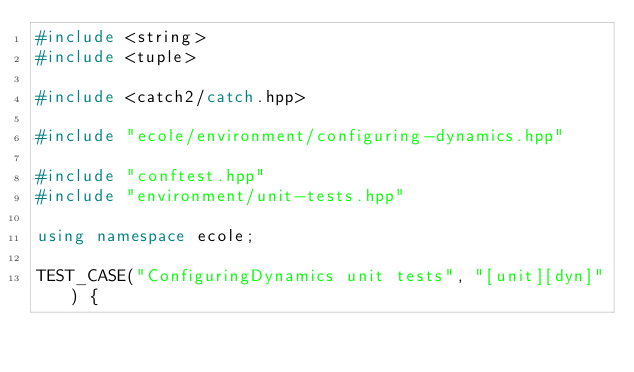<code> <loc_0><loc_0><loc_500><loc_500><_C++_>#include <string>
#include <tuple>

#include <catch2/catch.hpp>

#include "ecole/environment/configuring-dynamics.hpp"

#include "conftest.hpp"
#include "environment/unit-tests.hpp"

using namespace ecole;

TEST_CASE("ConfiguringDynamics unit tests", "[unit][dyn]") {</code> 